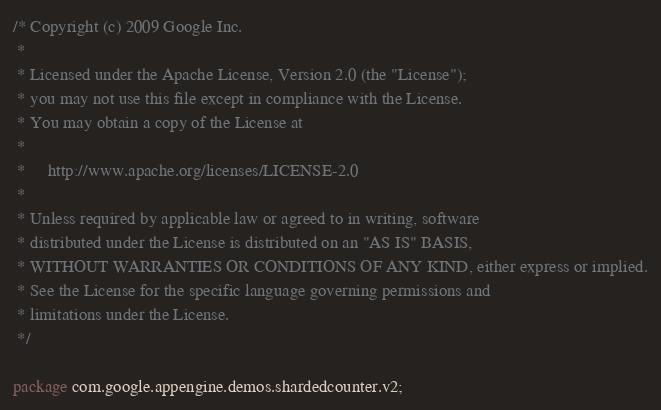<code> <loc_0><loc_0><loc_500><loc_500><_Java_>/* Copyright (c) 2009 Google Inc.
 *
 * Licensed under the Apache License, Version 2.0 (the "License");
 * you may not use this file except in compliance with the License.
 * You may obtain a copy of the License at
 *
 *     http://www.apache.org/licenses/LICENSE-2.0
 *
 * Unless required by applicable law or agreed to in writing, software
 * distributed under the License is distributed on an "AS IS" BASIS,
 * WITHOUT WARRANTIES OR CONDITIONS OF ANY KIND, either express or implied.
 * See the License for the specific language governing permissions and
 * limitations under the License.
 */

package com.google.appengine.demos.shardedcounter.v2;
</code> 